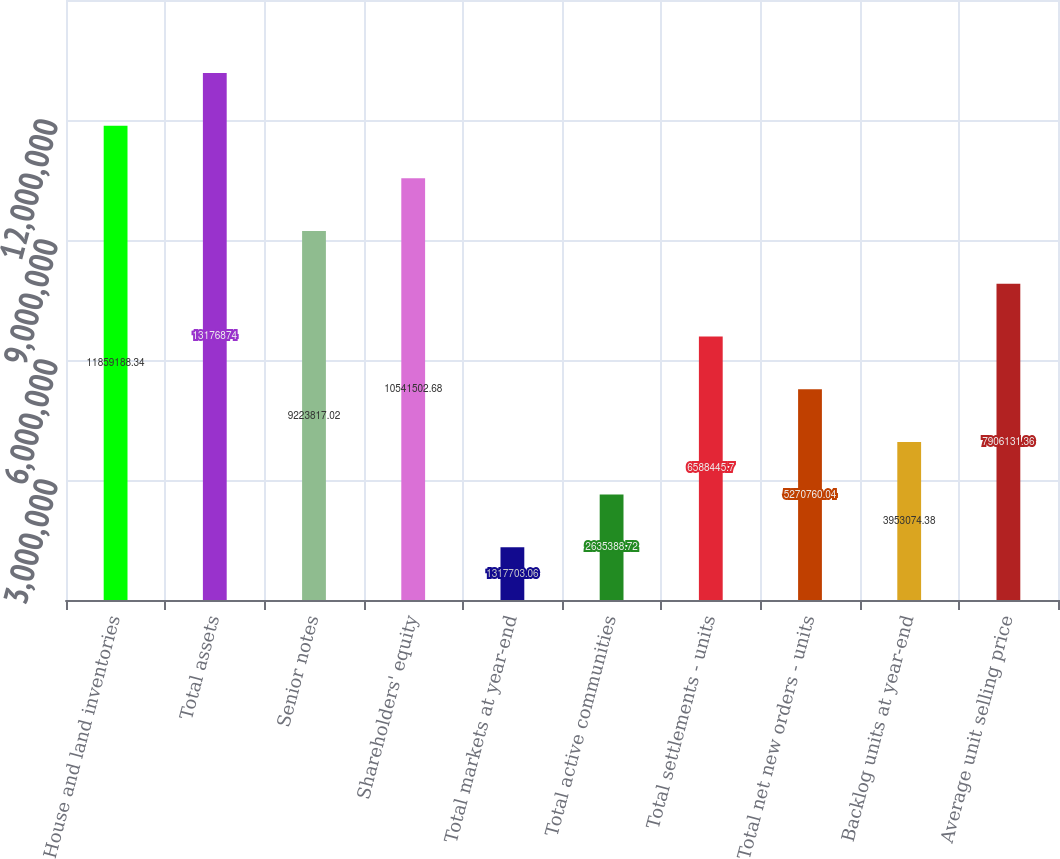<chart> <loc_0><loc_0><loc_500><loc_500><bar_chart><fcel>House and land inventories<fcel>Total assets<fcel>Senior notes<fcel>Shareholders' equity<fcel>Total markets at year-end<fcel>Total active communities<fcel>Total settlements - units<fcel>Total net new orders - units<fcel>Backlog units at year-end<fcel>Average unit selling price<nl><fcel>1.18592e+07<fcel>1.31769e+07<fcel>9.22382e+06<fcel>1.05415e+07<fcel>1.3177e+06<fcel>2.63539e+06<fcel>6.58845e+06<fcel>5.27076e+06<fcel>3.95307e+06<fcel>7.90613e+06<nl></chart> 